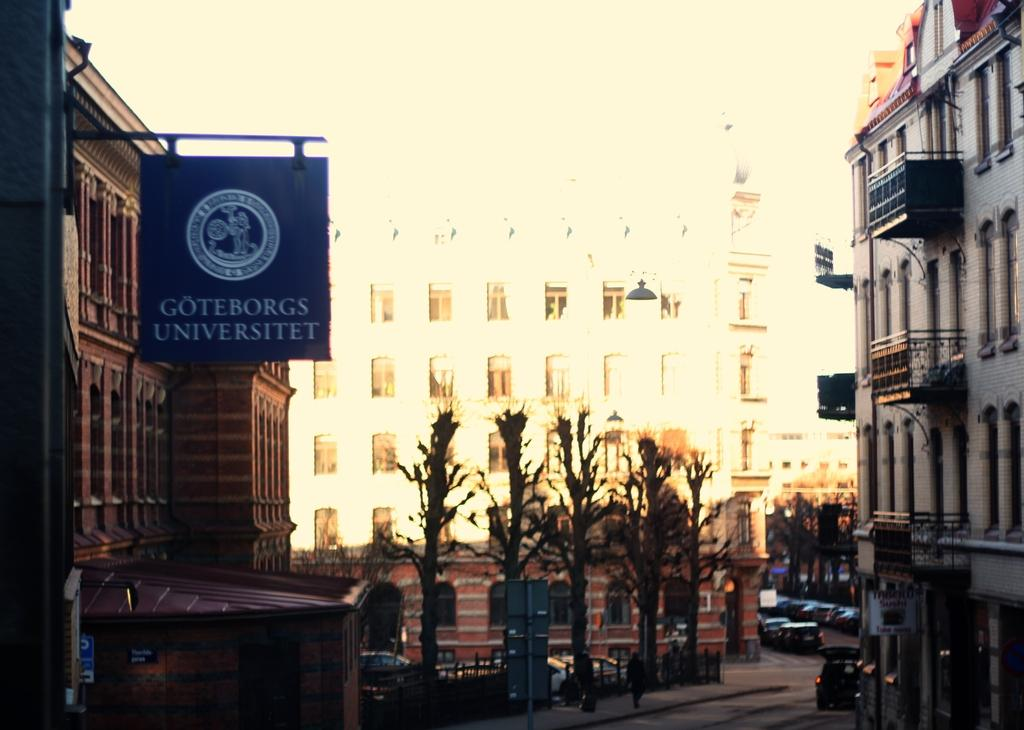What type of natural elements can be seen in the image? There are trees in the image. What type of man-made objects can be seen in the image? There are vehicles in the image. What is located on the left side of the image? There is a board on the left side of the image. What type of structures are present on either side of the image? There are buildings on either side of the image. What flavor of operation is being performed on the roof in the image? There is no operation or roof present in the image. What type of flavor can be seen on the trees in the image? There is no flavor associated with the trees in the image; they are natural elements. 